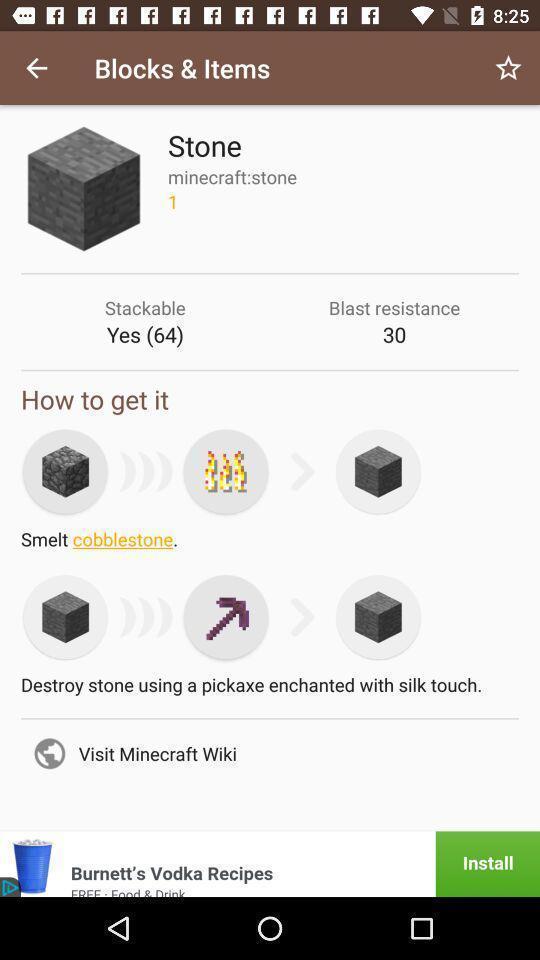Please provide a description for this image. Page displays items in app. 